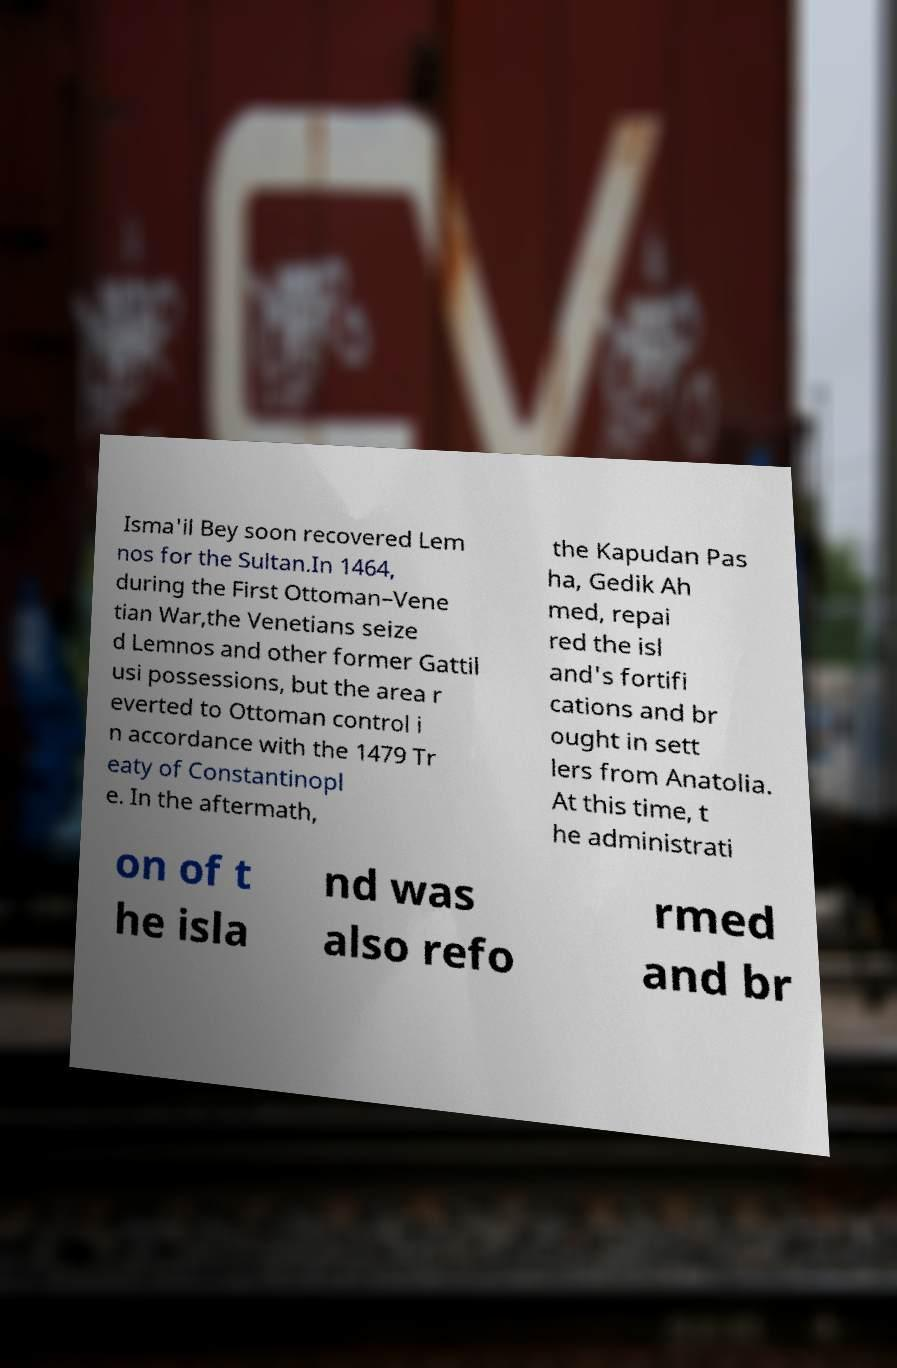Please read and relay the text visible in this image. What does it say? Isma'il Bey soon recovered Lem nos for the Sultan.In 1464, during the First Ottoman–Vene tian War,the Venetians seize d Lemnos and other former Gattil usi possessions, but the area r everted to Ottoman control i n accordance with the 1479 Tr eaty of Constantinopl e. In the aftermath, the Kapudan Pas ha, Gedik Ah med, repai red the isl and's fortifi cations and br ought in sett lers from Anatolia. At this time, t he administrati on of t he isla nd was also refo rmed and br 